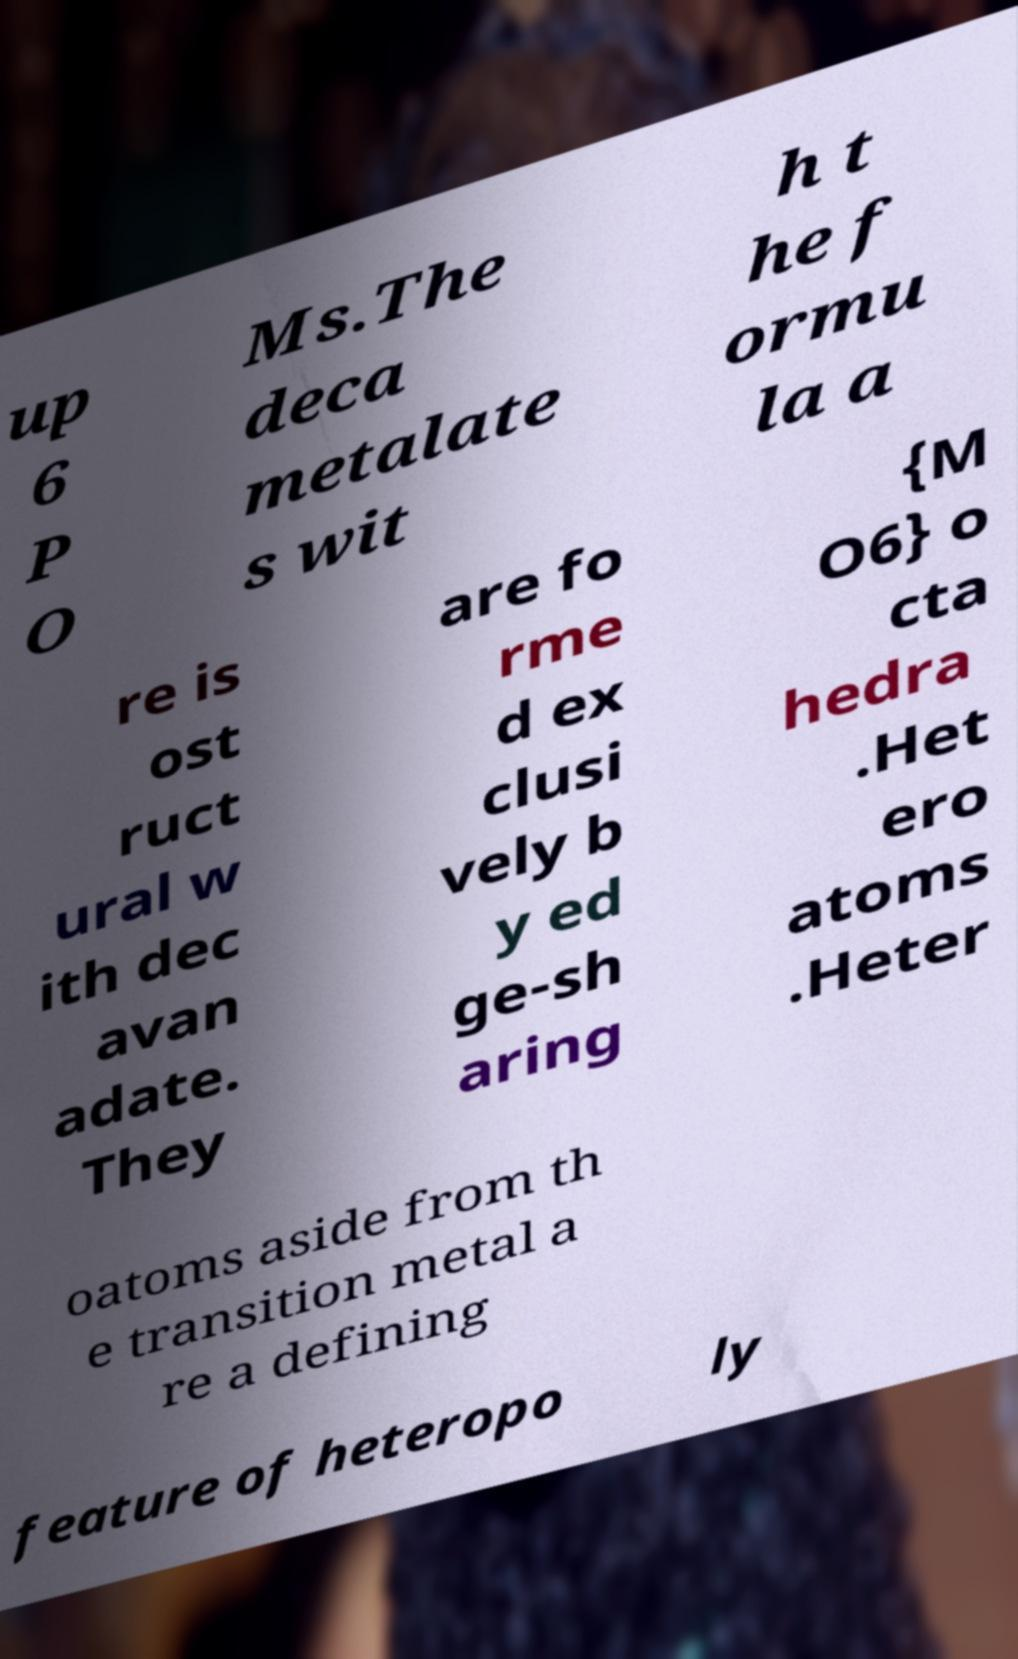There's text embedded in this image that I need extracted. Can you transcribe it verbatim? up 6 P O Ms.The deca metalate s wit h t he f ormu la a re is ost ruct ural w ith dec avan adate. They are fo rme d ex clusi vely b y ed ge-sh aring {M O6} o cta hedra .Het ero atoms .Heter oatoms aside from th e transition metal a re a defining feature of heteropo ly 